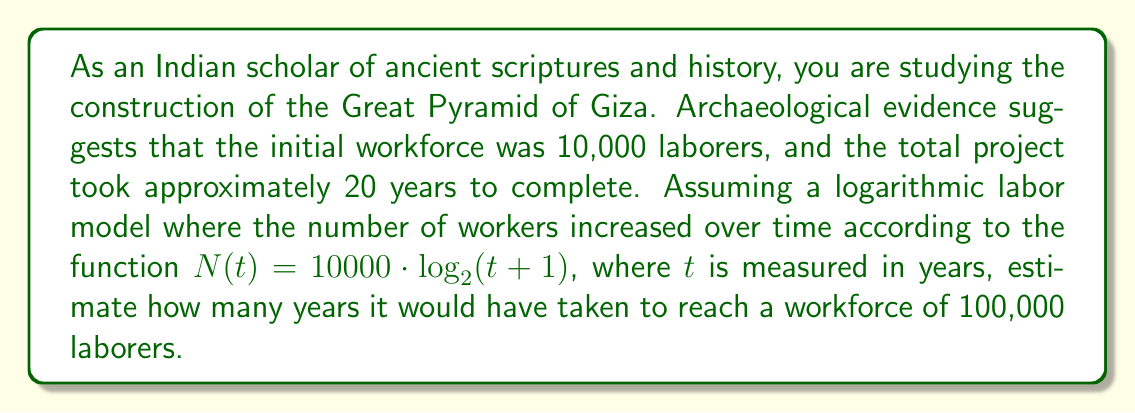Show me your answer to this math problem. To solve this problem, we need to use the given logarithmic function and solve for $t$ when $N(t) = 100000$. Let's break it down step by step:

1) We start with the equation:
   $N(t) = 10000 \cdot \log_2(t+1)$

2) We want to find $t$ when $N(t) = 100000$, so we substitute this:
   $100000 = 10000 \cdot \log_2(t+1)$

3) Divide both sides by 10000:
   $10 = \log_2(t+1)$

4) To solve for $t$, we need to apply the inverse function of $\log_2$, which is $2^x$:
   $2^{10} = t+1$

5) Calculate $2^{10}$:
   $1024 = t+1$

6) Subtract 1 from both sides:
   $1023 = t$

Therefore, it would take approximately 1023 years to reach a workforce of 100,000 laborers according to this logarithmic model.

This result highlights an important aspect of logarithmic growth: it starts quickly but slows down over time. In reality, the ancient Egyptians likely used a different labor model, as this timeline far exceeds the actual construction period of the Great Pyramid.
Answer: Approximately 1023 years 